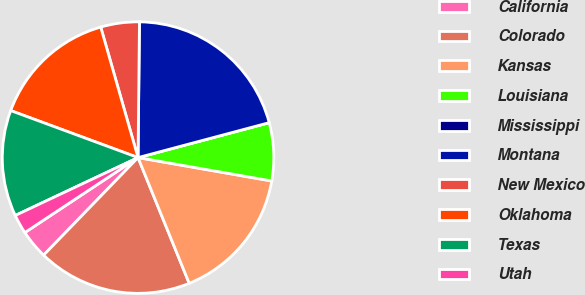Convert chart to OTSL. <chart><loc_0><loc_0><loc_500><loc_500><pie_chart><fcel>California<fcel>Colorado<fcel>Kansas<fcel>Louisiana<fcel>Mississippi<fcel>Montana<fcel>New Mexico<fcel>Oklahoma<fcel>Texas<fcel>Utah<nl><fcel>3.45%<fcel>18.39%<fcel>16.09%<fcel>6.9%<fcel>0.0%<fcel>20.69%<fcel>4.6%<fcel>14.94%<fcel>12.64%<fcel>2.3%<nl></chart> 